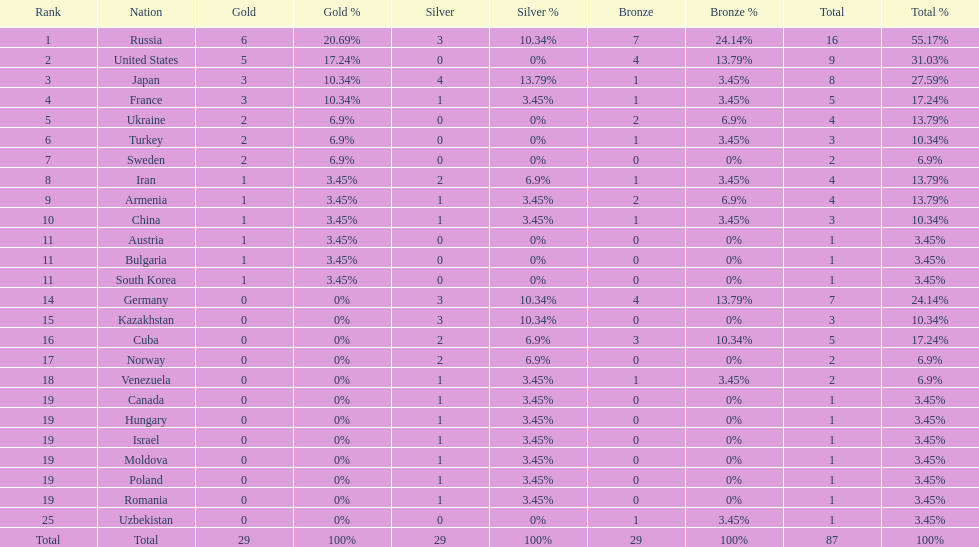What is the total amount of nations with more than 5 bronze medals? 1. 